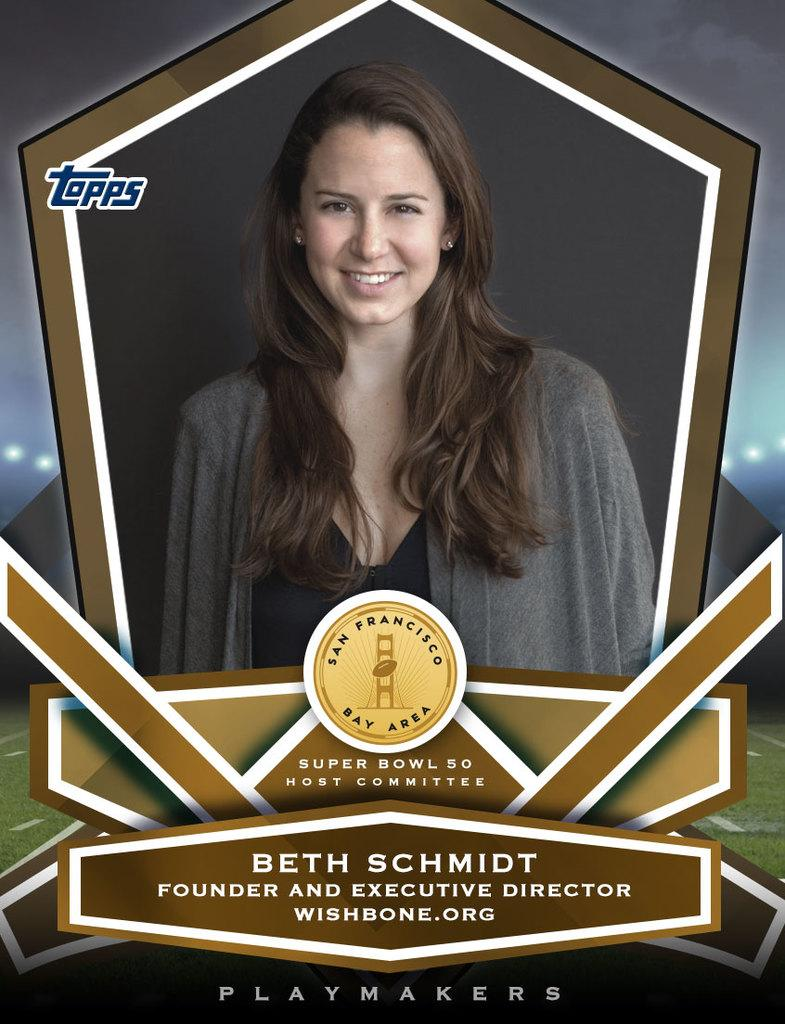What is the main subject of the picture? The main subject of the picture is an image of a woman. What is the woman doing in the image? The woman is smiling in the image. Where is the image located? The image is on a batch. What is written on the batch? The name "San Francisco" is on the batch. How many goldfish are swimming in the image? There are no goldfish present in the image. What is the name of the woman's daughter in the image? There is no information about a daughter in the image. 